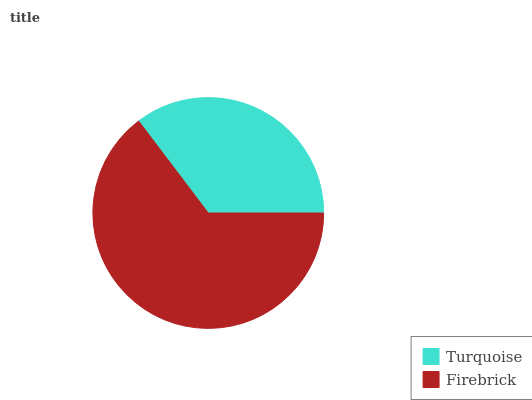Is Turquoise the minimum?
Answer yes or no. Yes. Is Firebrick the maximum?
Answer yes or no. Yes. Is Firebrick the minimum?
Answer yes or no. No. Is Firebrick greater than Turquoise?
Answer yes or no. Yes. Is Turquoise less than Firebrick?
Answer yes or no. Yes. Is Turquoise greater than Firebrick?
Answer yes or no. No. Is Firebrick less than Turquoise?
Answer yes or no. No. Is Firebrick the high median?
Answer yes or no. Yes. Is Turquoise the low median?
Answer yes or no. Yes. Is Turquoise the high median?
Answer yes or no. No. Is Firebrick the low median?
Answer yes or no. No. 